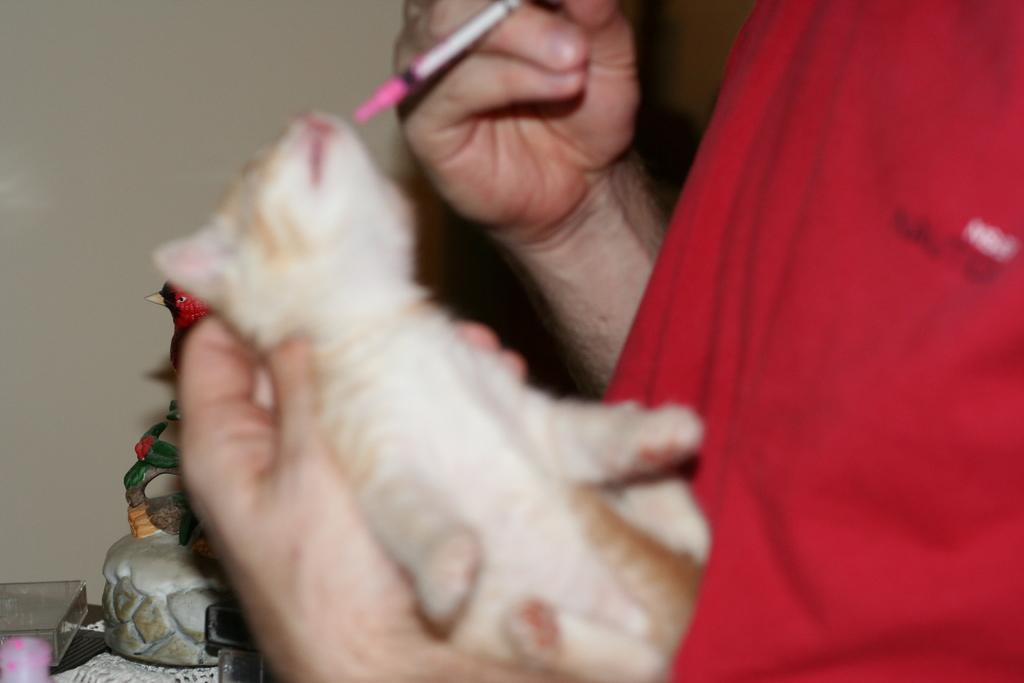What is the main subject in the front of the image? There is a person standing in the front of the image. What is the person holding in their hand? The person is holding an animal in their hand. What can be seen in the background of the image? There are toys visible in the background of the image. How many chairs are visible on the side of the image? There are no chairs visible in the image. 